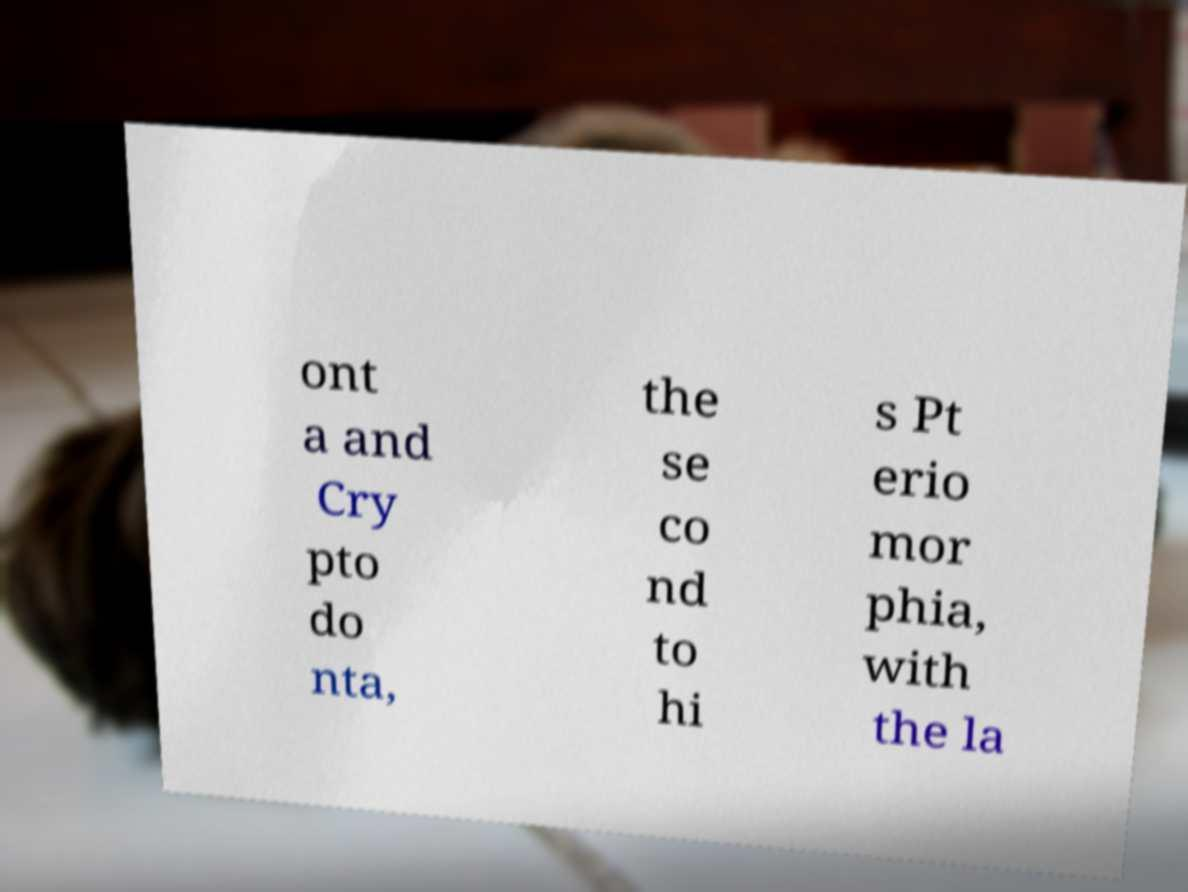Please identify and transcribe the text found in this image. ont a and Cry pto do nta, the se co nd to hi s Pt erio mor phia, with the la 